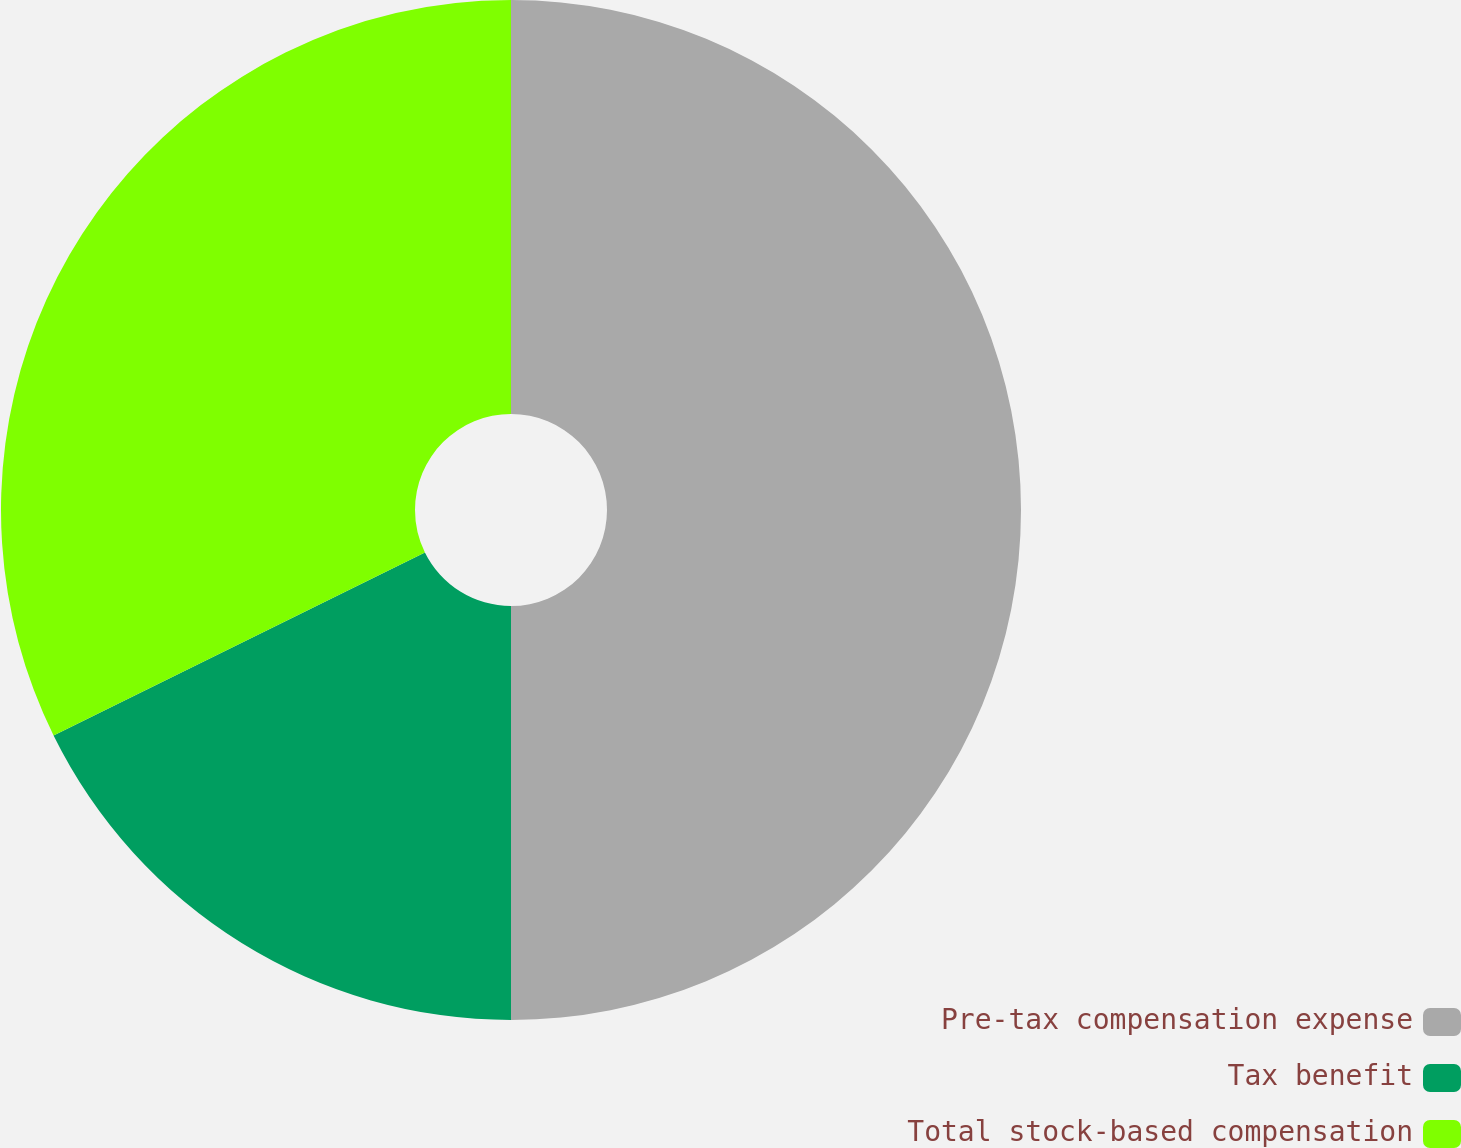Convert chart. <chart><loc_0><loc_0><loc_500><loc_500><pie_chart><fcel>Pre-tax compensation expense<fcel>Tax benefit<fcel>Total stock-based compensation<nl><fcel>50.0%<fcel>17.71%<fcel>32.29%<nl></chart> 